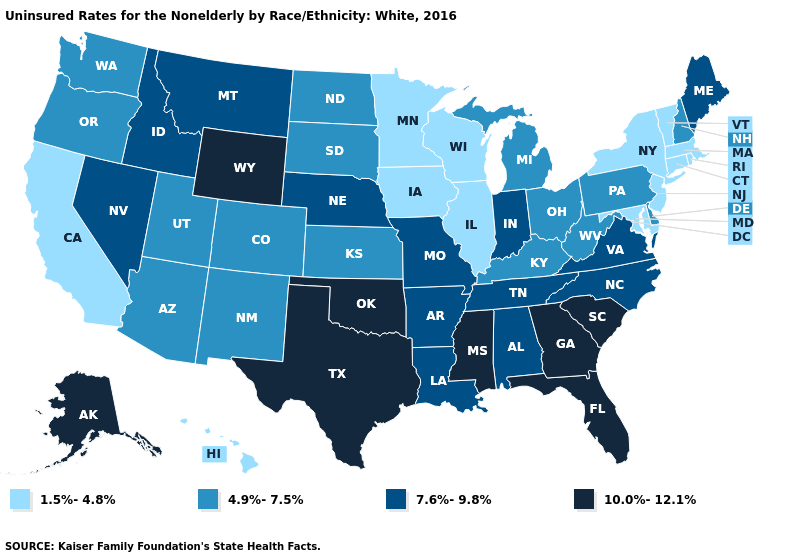Among the states that border Vermont , which have the highest value?
Keep it brief. New Hampshire. What is the value of Utah?
Write a very short answer. 4.9%-7.5%. Name the states that have a value in the range 7.6%-9.8%?
Answer briefly. Alabama, Arkansas, Idaho, Indiana, Louisiana, Maine, Missouri, Montana, Nebraska, Nevada, North Carolina, Tennessee, Virginia. What is the highest value in the MidWest ?
Answer briefly. 7.6%-9.8%. Which states have the lowest value in the MidWest?
Give a very brief answer. Illinois, Iowa, Minnesota, Wisconsin. Does Florida have the highest value in the South?
Be succinct. Yes. What is the lowest value in the USA?
Write a very short answer. 1.5%-4.8%. What is the lowest value in the USA?
Be succinct. 1.5%-4.8%. Name the states that have a value in the range 7.6%-9.8%?
Short answer required. Alabama, Arkansas, Idaho, Indiana, Louisiana, Maine, Missouri, Montana, Nebraska, Nevada, North Carolina, Tennessee, Virginia. Name the states that have a value in the range 7.6%-9.8%?
Write a very short answer. Alabama, Arkansas, Idaho, Indiana, Louisiana, Maine, Missouri, Montana, Nebraska, Nevada, North Carolina, Tennessee, Virginia. What is the highest value in the USA?
Be succinct. 10.0%-12.1%. What is the value of Ohio?
Answer briefly. 4.9%-7.5%. Among the states that border New York , which have the highest value?
Answer briefly. Pennsylvania. Which states have the lowest value in the Northeast?
Keep it brief. Connecticut, Massachusetts, New Jersey, New York, Rhode Island, Vermont. Which states have the highest value in the USA?
Answer briefly. Alaska, Florida, Georgia, Mississippi, Oklahoma, South Carolina, Texas, Wyoming. 